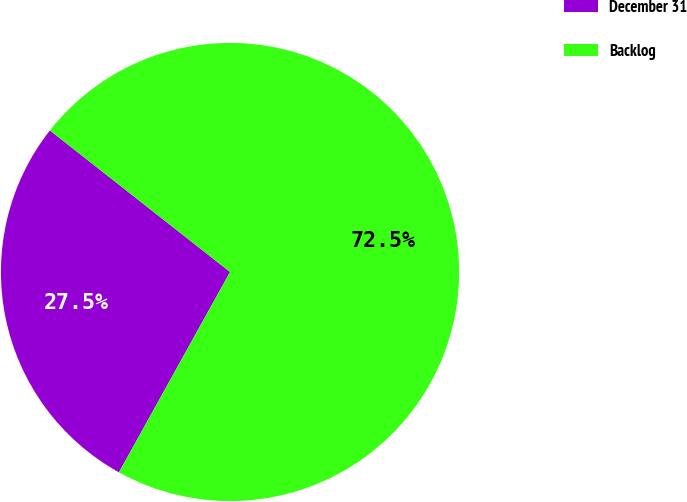Convert chart to OTSL. <chart><loc_0><loc_0><loc_500><loc_500><pie_chart><fcel>December 31<fcel>Backlog<nl><fcel>27.54%<fcel>72.46%<nl></chart> 